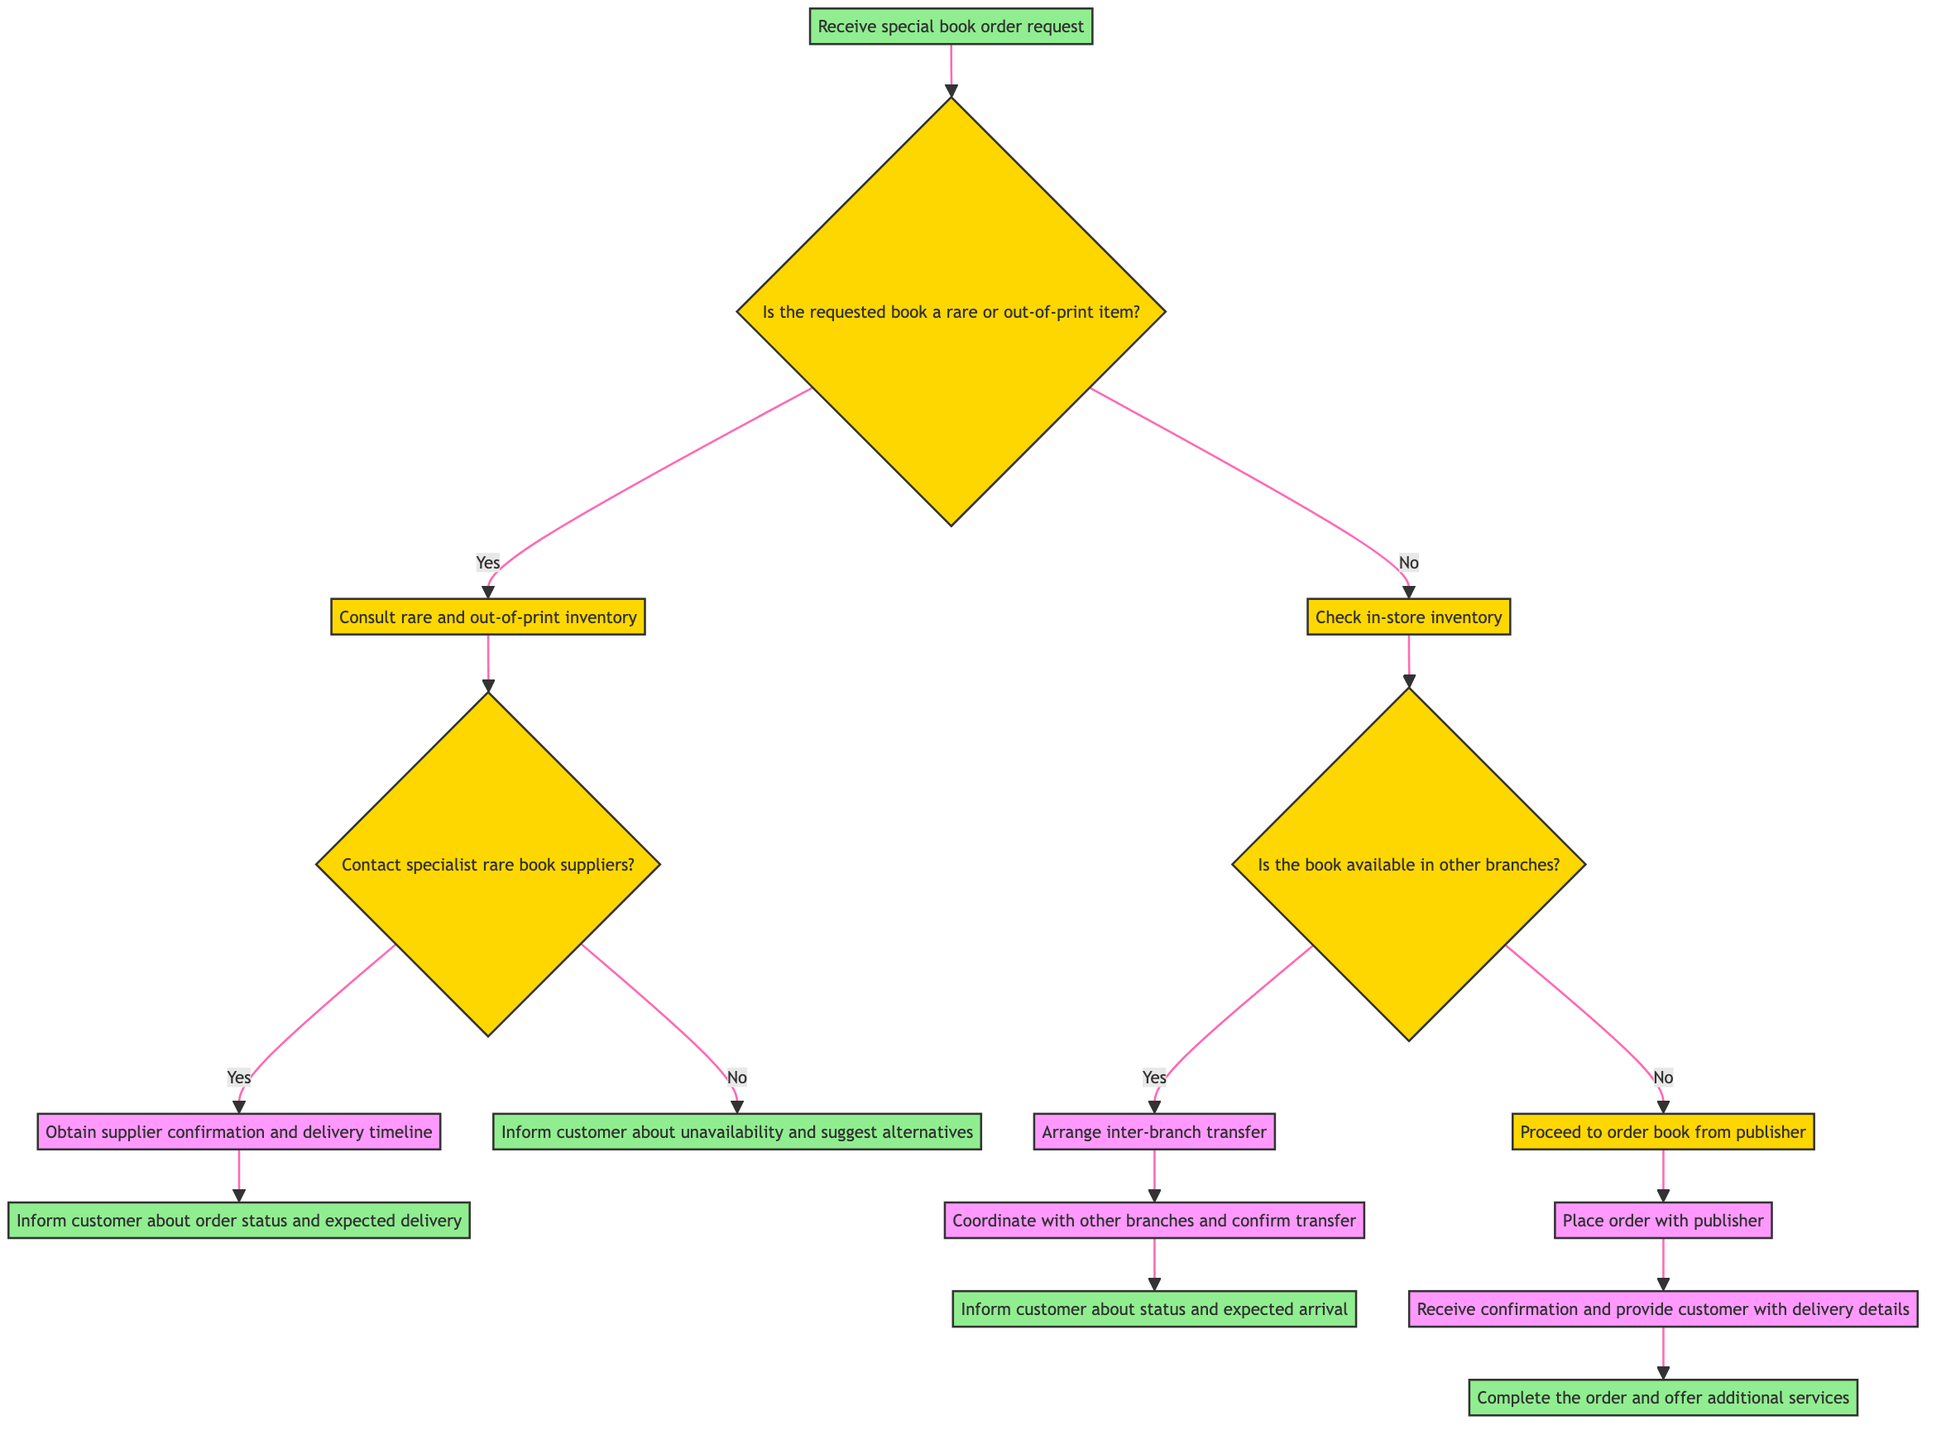What is the starting point of the decision tree? The starting point is the first node labeled "Receive special book order request." This is where the entire process begins.
Answer: Receive special book order request How many decisions are made after checking in-store inventory? After checking in-store inventory, there are two decisions made: whether the book is available in other branches or to proceed to order the book from the publisher.
Answer: Two What happens if the answer is 'Yes' to whether the requested book is a rare or out-of-print item? If it's a 'Yes', the next step is to "Consult rare and out-of-print inventory." This is a direct outcome of the decision regarding the rarity of the book.
Answer: Consult rare and out-of-print inventory If the book is available in other branches, what action is taken next? If the book is available in other branches, the action taken is to "Arrange inter-branch transfer," which facilitates getting the book from another location.
Answer: Arrange inter-branch transfer What must happen before confirming the order status and expected delivery timeline? Before confirming the order status and expected delivery timeline, it is essential to "Obtain supplier confirmation and delivery timeline" if contacting specialist suppliers. This step is necessary to understand what to communicate to the customer.
Answer: Obtain supplier confirmation and delivery timeline What is the final action taken if the order from the publisher is placed successfully? If the order from the publisher is placed successfully, the final action is to "Complete the order and offer any additional services," which ensures customer satisfaction.
Answer: Complete the order and offer any additional services What outcome occurs if the book is not available in other branches? If the book is not available in other branches, the outcome is to "Proceed to order book from publisher," indicating that alternative arrangements need to be made.
Answer: Proceed to order book from publisher What happens if the contact with suppliers does not yield a 'Yes'? If the contact with specialist suppliers does not yield a 'Yes', then the action will be to "Inform customer about unavailability and suggest alternatives," which provides the customer with necessary suggestions.
Answer: Inform customer about unavailability and suggest alternatives How many actions are there in total within the decision tree? There are six distinct actions identified by the outcomes in this decision tree, reflecting the various steps involved in addressing book order requests.
Answer: Six 